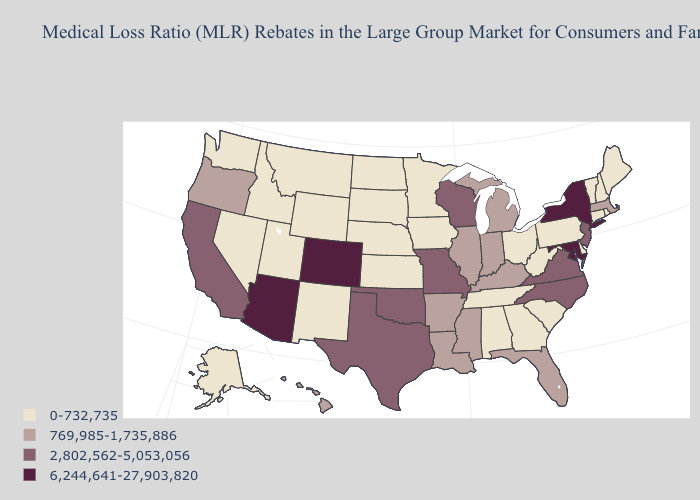Name the states that have a value in the range 769,985-1,735,886?
Write a very short answer. Arkansas, Florida, Hawaii, Illinois, Indiana, Kentucky, Louisiana, Massachusetts, Michigan, Mississippi, Oregon. Name the states that have a value in the range 6,244,641-27,903,820?
Short answer required. Arizona, Colorado, Maryland, New York. Does Nebraska have the highest value in the USA?
Keep it brief. No. What is the value of Pennsylvania?
Give a very brief answer. 0-732,735. Name the states that have a value in the range 2,802,562-5,053,056?
Answer briefly. California, Missouri, New Jersey, North Carolina, Oklahoma, Texas, Virginia, Wisconsin. What is the value of Arkansas?
Keep it brief. 769,985-1,735,886. What is the value of Missouri?
Give a very brief answer. 2,802,562-5,053,056. Does Colorado have the lowest value in the West?
Be succinct. No. Which states hav the highest value in the Northeast?
Write a very short answer. New York. What is the value of Montana?
Short answer required. 0-732,735. How many symbols are there in the legend?
Write a very short answer. 4. What is the value of Maryland?
Give a very brief answer. 6,244,641-27,903,820. Does the first symbol in the legend represent the smallest category?
Quick response, please. Yes. What is the lowest value in the USA?
Be succinct. 0-732,735. 